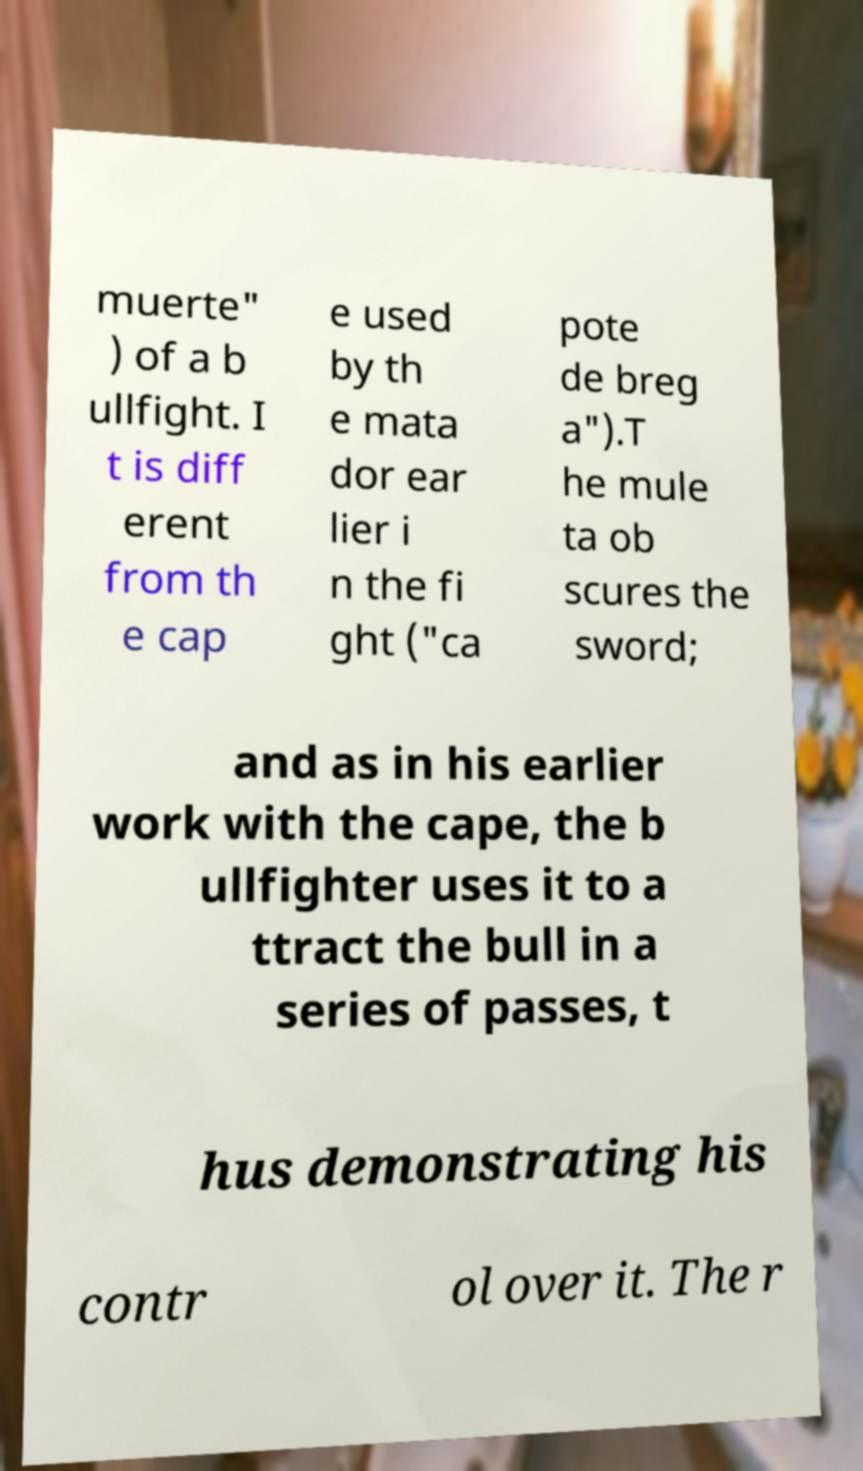Please identify and transcribe the text found in this image. muerte" ) of a b ullfight. I t is diff erent from th e cap e used by th e mata dor ear lier i n the fi ght ("ca pote de breg a").T he mule ta ob scures the sword; and as in his earlier work with the cape, the b ullfighter uses it to a ttract the bull in a series of passes, t hus demonstrating his contr ol over it. The r 